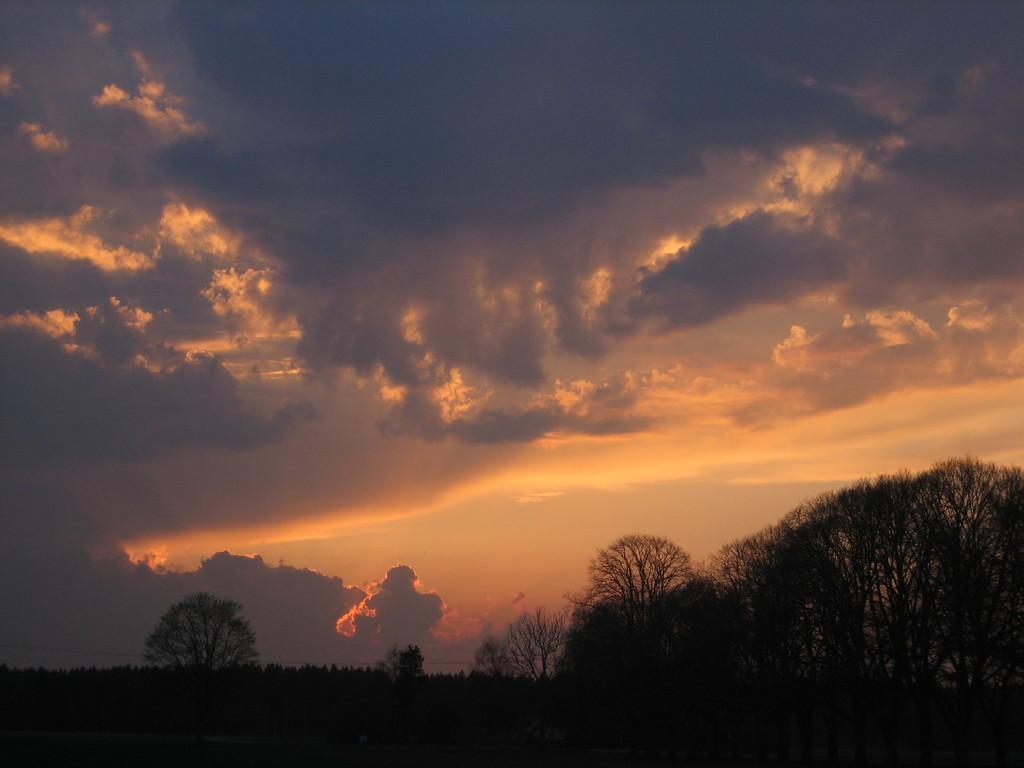How would you summarize this image in a sentence or two? This image is taken during the evening time. In this image we can see many trees. In the background we can see the sky with the clouds. 